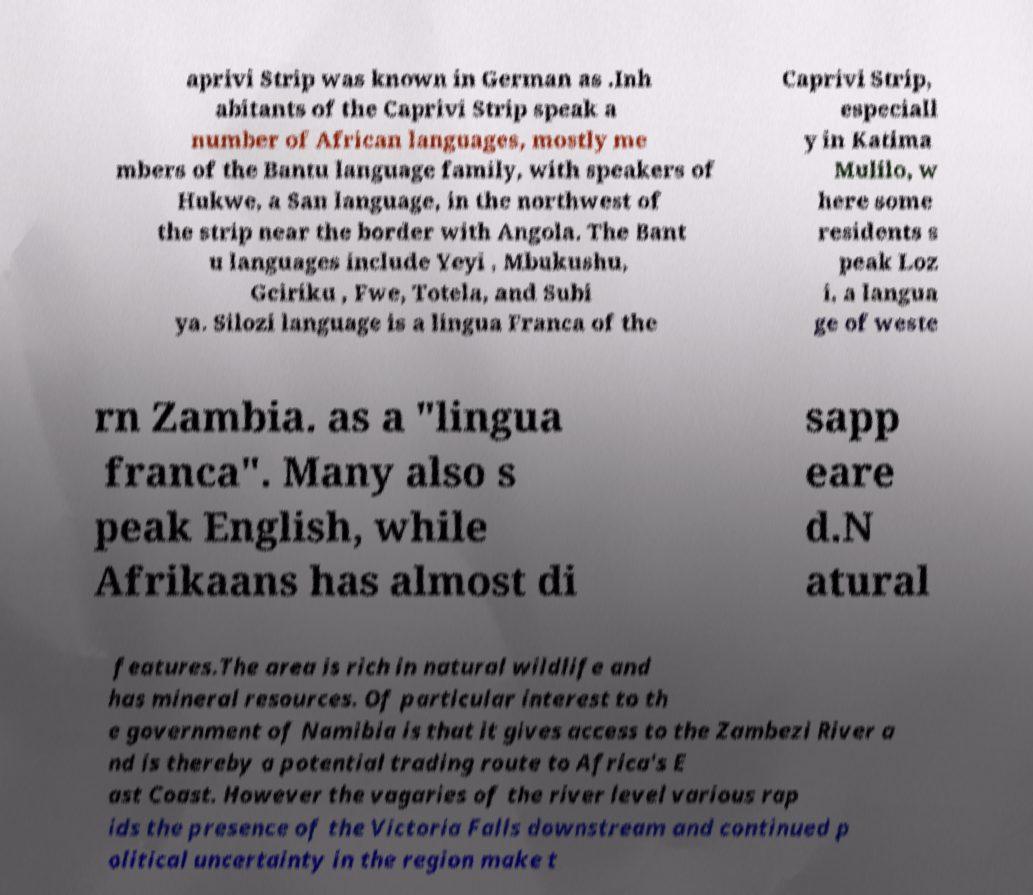Could you extract and type out the text from this image? aprivi Strip was known in German as .Inh abitants of the Caprivi Strip speak a number of African languages, mostly me mbers of the Bantu language family, with speakers of Hukwe, a San language, in the northwest of the strip near the border with Angola. The Bant u languages include Yeyi , Mbukushu, Gciriku , Fwe, Totela, and Subi ya. Silozi language is a lingua Franca of the Caprivi Strip, especiall y in Katima Mulilo, w here some residents s peak Loz i, a langua ge of weste rn Zambia. as a "lingua franca". Many also s peak English, while Afrikaans has almost di sapp eare d.N atural features.The area is rich in natural wildlife and has mineral resources. Of particular interest to th e government of Namibia is that it gives access to the Zambezi River a nd is thereby a potential trading route to Africa's E ast Coast. However the vagaries of the river level various rap ids the presence of the Victoria Falls downstream and continued p olitical uncertainty in the region make t 